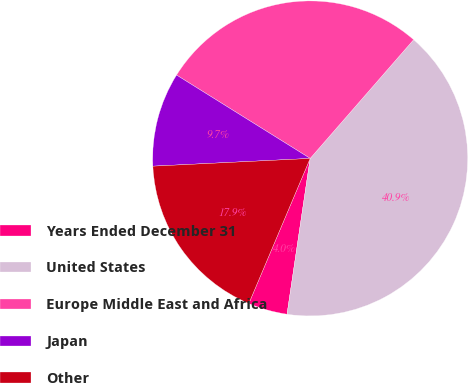Convert chart to OTSL. <chart><loc_0><loc_0><loc_500><loc_500><pie_chart><fcel>Years Ended December 31<fcel>United States<fcel>Europe Middle East and Africa<fcel>Japan<fcel>Other<nl><fcel>4.02%<fcel>40.94%<fcel>27.53%<fcel>9.66%<fcel>17.85%<nl></chart> 